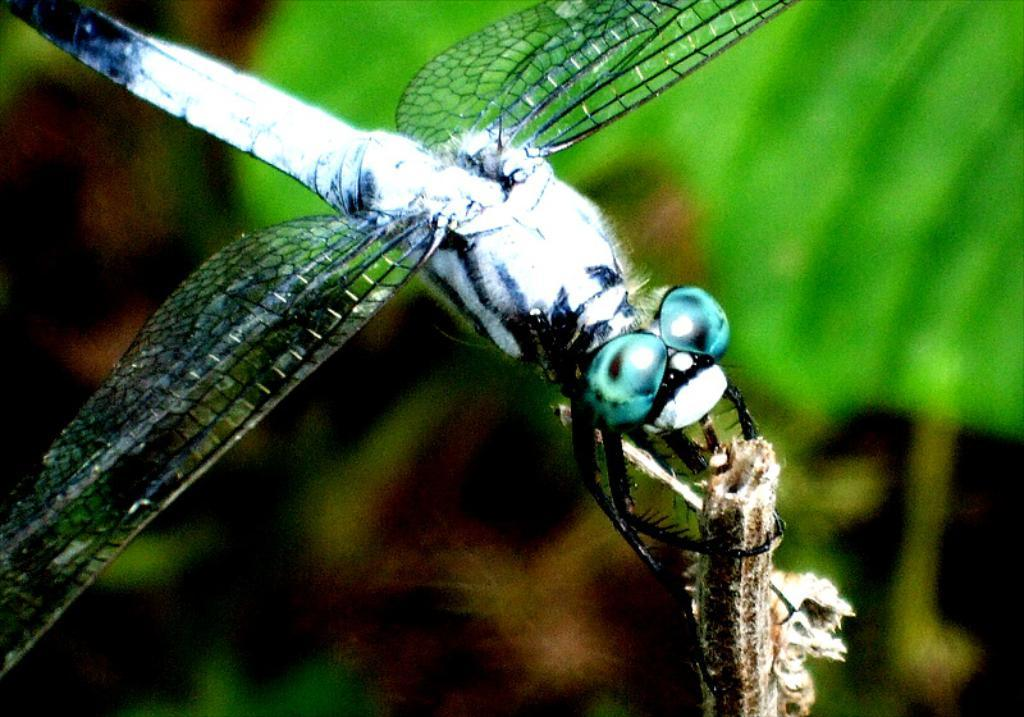What type of creature is present in the image? There is an insect in the image. What surface is the insect situated on? The insect is on a wooden object. How would you describe the background of the image? The background of the image is blurry. What type of glass is the insect drinking from in the image? There is no glass or any indication of the insect drinking in the image. What kind of noise can be heard coming from the insect in the image? There is no sound or noise associated with the insect in the image. 